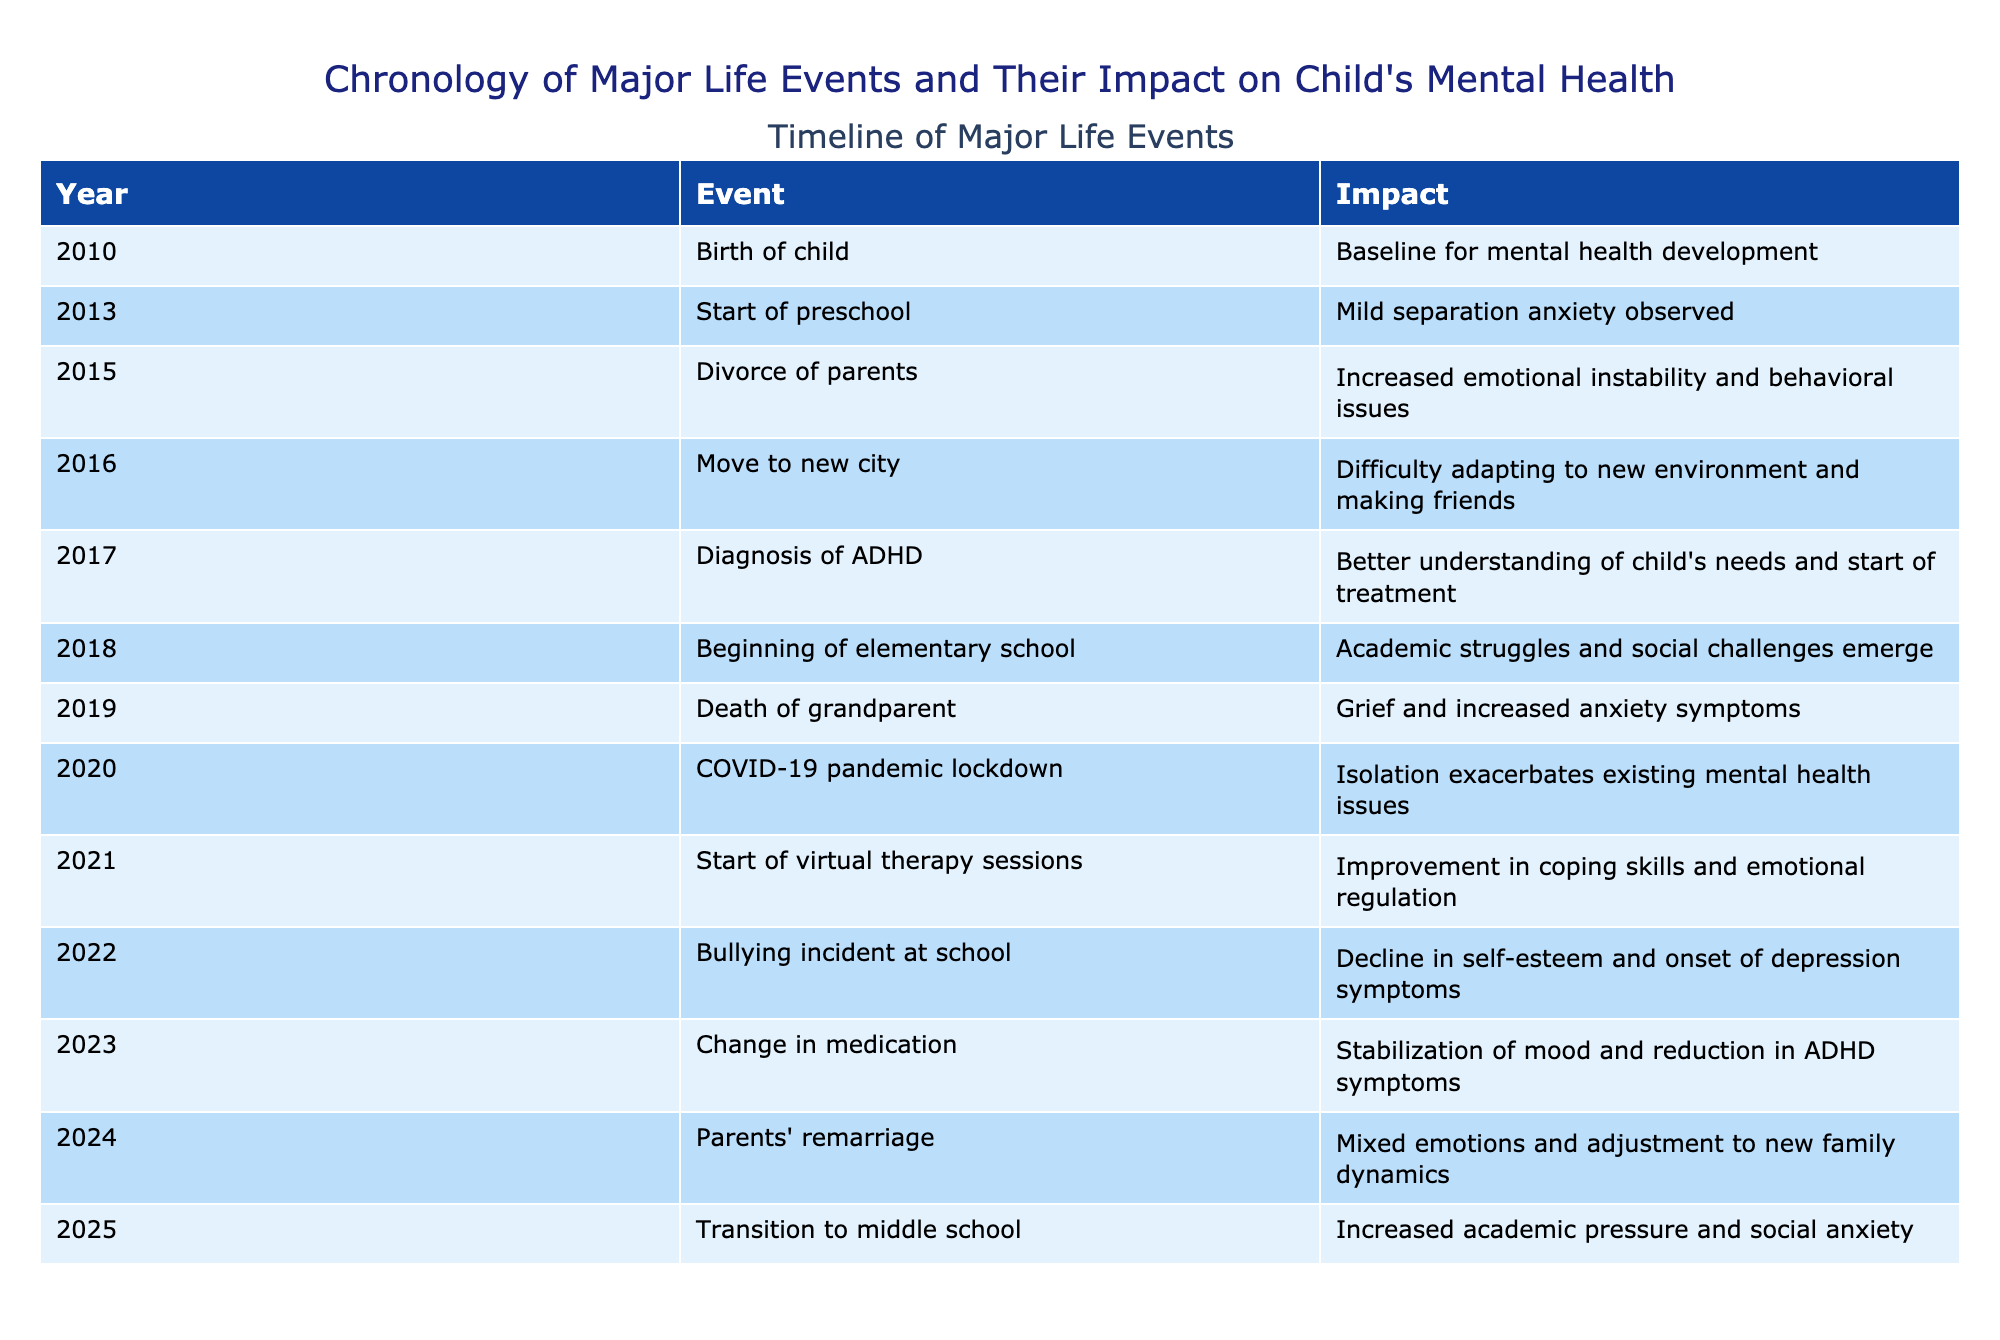What major life event occurred in 2015? The table shows that in 2015, the parents' divorce took place. This event is marked as significant in the timeline.
Answer: Divorce of parents How did the COVID-19 pandemic impact the child's mental health? According to the table, the COVID-19 pandemic lockdown in 2020 led to isolation, which exacerbated existing mental health issues.
Answer: Isolation exacerbates existing mental health issues What event was associated with increased anxiety symptoms? The table indicates that the death of a grandparent in 2019 was linked to grief and increased anxiety symptoms in the child.
Answer: Death of grandparent Was there an event in 2023 that led to a reduction in symptoms? Yes, the table states that the change in medication in 2023 resulted in stabilization of mood and reduction in ADHD symptoms.
Answer: Yes What pattern can be observed regarding school transitions and mental health? The timeline shows that both the transition to elementary school in 2018 and to middle school in 2025 are associated with challenges: academic struggles and increased academic pressure/social anxiety, respectively. Therefore, school transitions appear to correlate with increased mental health challenges.
Answer: School transitions correlate with increased mental health challenges 